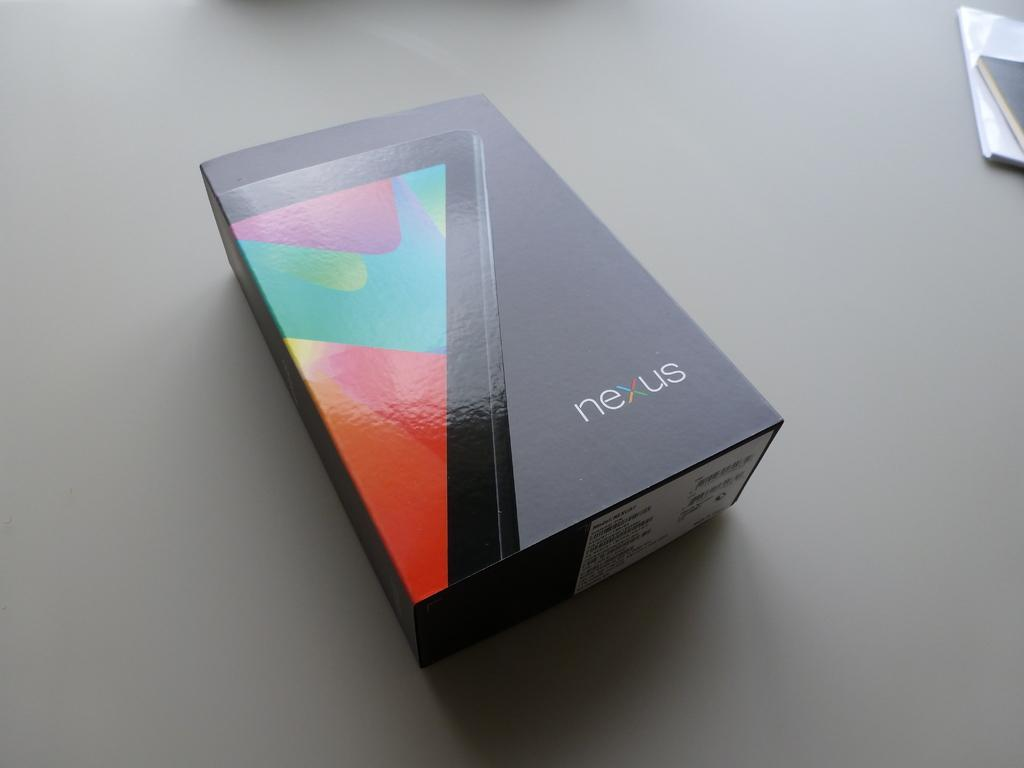<image>
Relay a brief, clear account of the picture shown. the word Nexus is on a dark box 